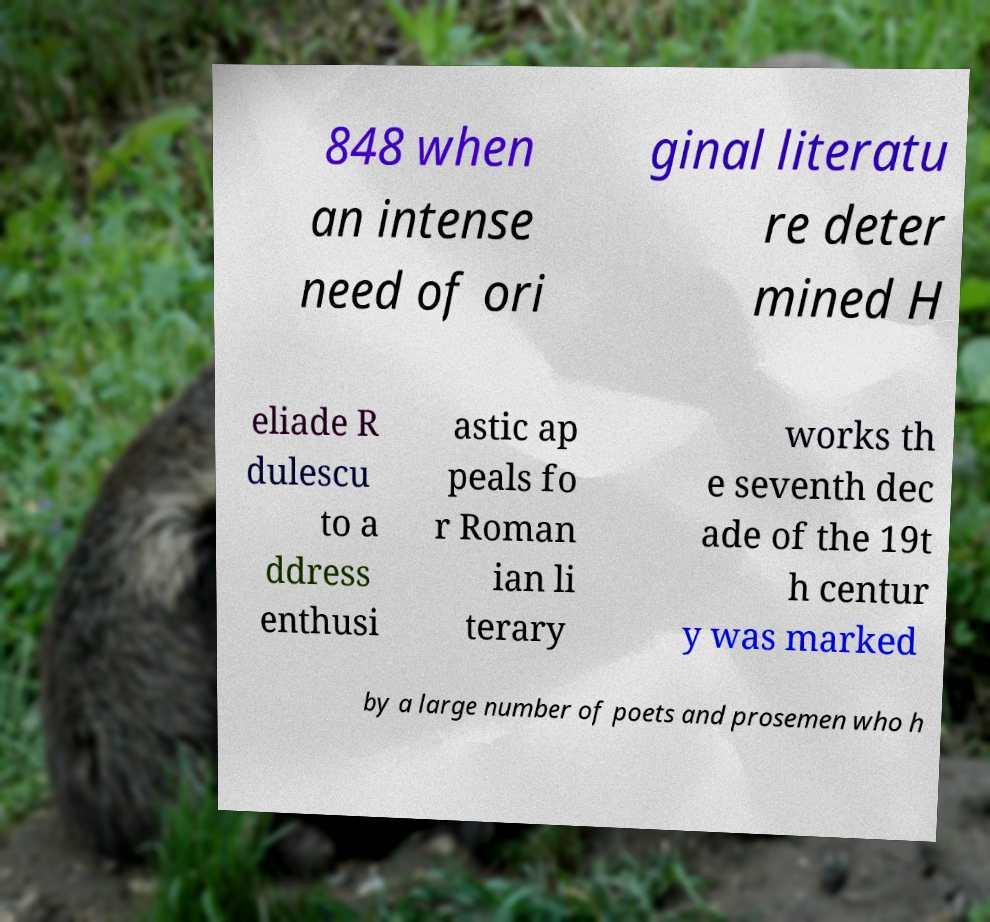Could you assist in decoding the text presented in this image and type it out clearly? 848 when an intense need of ori ginal literatu re deter mined H eliade R dulescu to a ddress enthusi astic ap peals fo r Roman ian li terary works th e seventh dec ade of the 19t h centur y was marked by a large number of poets and prosemen who h 